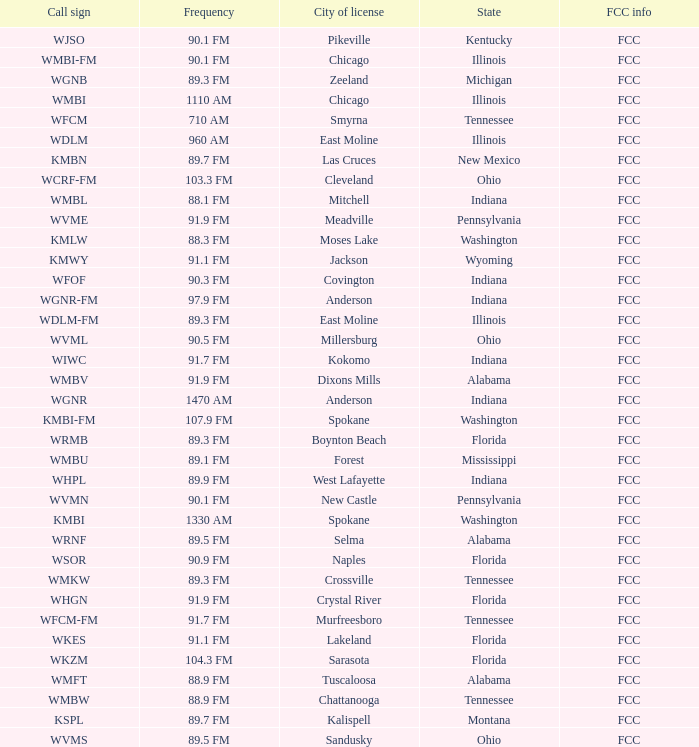What state is the radio station in that has a frequency of 90.1 FM and a city license in New Castle? Pennsylvania. 